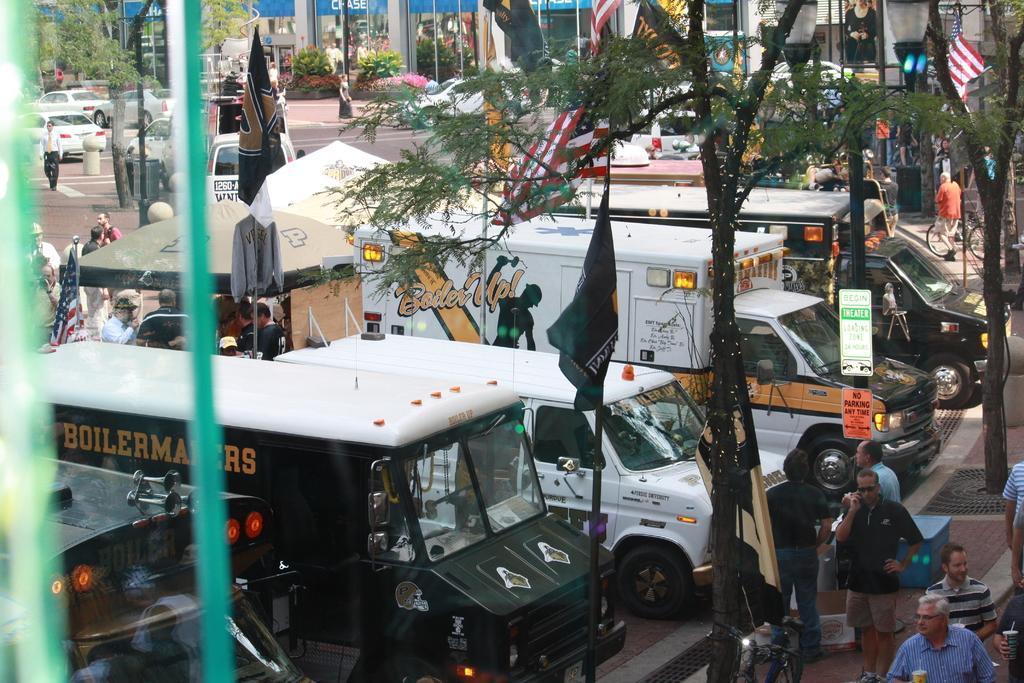Could you give a brief overview of what you see in this image? This picture might be taken outside of the city. In this image, on the right side, we can see group of people, trees, flags. On the left side, we can also see some vehicles, flags. In the background, we can see some buildings, vehicles, trees. 